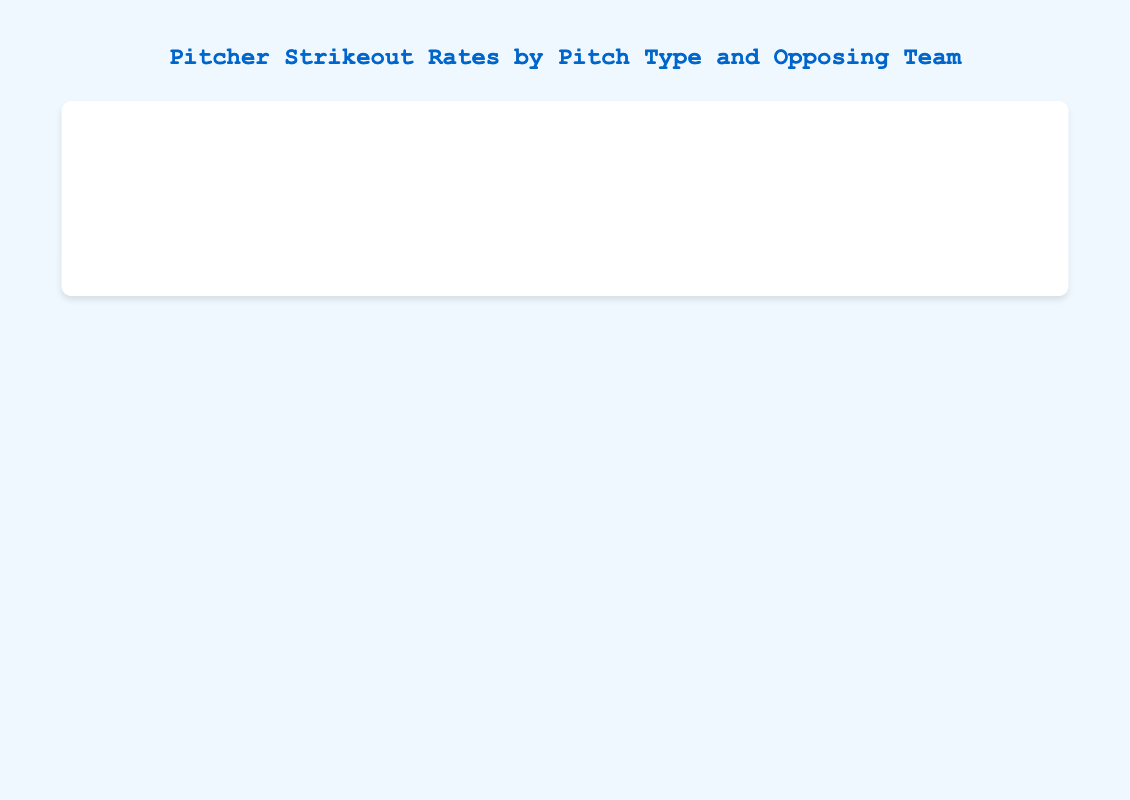Which pitch type does Max Scherzer use most against the New York Yankees? The longest bar for Max Scherzer against the New York Yankees is the red bar, representing the Fastball pitch type.
Answer: Fastball Which pitcher has the highest strikeout rate using a Curveball against any opposing team? Jacob deGrom has a high strikeout rate using a Curveball against the Philadelphia Phillies, but the tallest yellow bar (Curveball) is for Clayton Kershaw against the Houston Astros.
Answer: Clayton Kershaw How does Clayton Kershaw's Fastball strikeout rate compare to his Slider strikeout rate against the Houston Astros? For Clayton Kershaw vs Houston Astros, the height of the blue bar (Slider) is higher than the red bar (Fastball), indicating a higher strikeout rate using the Slider.
Answer: The Slider is higher What is the total strikeout rate for Justin Verlander against the Oakland Athletics? Summing up Justin Verlander's bars for the Oakland Athletics: Fastball (20) + Slider (23) + Curveball (12) + Changeup (4) equals 59.
Answer: 59 Which pitcher has the most balanced strikeout rates across all pitch types for any opposing team? By examining the length of the bars, Justin Verlander against the Los Angeles Angels has relatively balanced strikeout rates in all pitch types: Fastball (19), Slider (22), Curveball (10), Changeup (8).
Answer: Justin Verlander vs Los Angeles Angels On which pitch type does Jacob deGrom rely more when facing the Atlanta Braves? The longest bar for Jacob deGrom against the Atlanta Braves is the blue bar, representing the Slider.
Answer: Slider Comparing Max Scherzer against the New York Yankees and Boston Red Sox, which pitch type shows the most consistent strikeout rate? Both teams show consistent length of the red bars, representing the Fastball. The difference is minor compared to other pitch types.
Answer: Fastball Which opposing team has Gerrit Cole's highest Fastball strikeout rate? The Fastball bar (red) is longer for Gerrit Cole against the Tampa Bay Rays than against the Toronto Blue Jays.
Answer: Tampa Bay Rays 